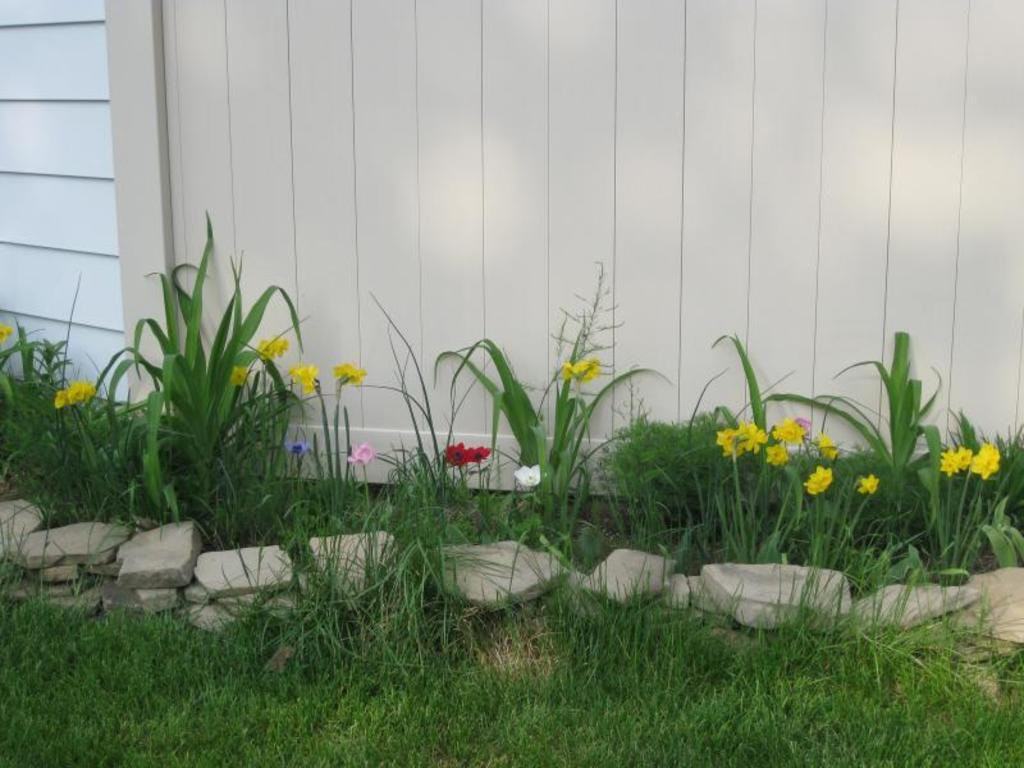What type of vegetation can be seen in the image? There is grass in the image. What other objects can be seen in the image? There are stones and plants with flowers in the image. What is visible in the background of the image? There is a wall in the background of the image. How many eggs are visible in the image? There are no eggs present in the image. What type of drain is installed in the grass? There is no drain visible in the image; it only features grass, stones, plants with flowers, and a wall in the background. 